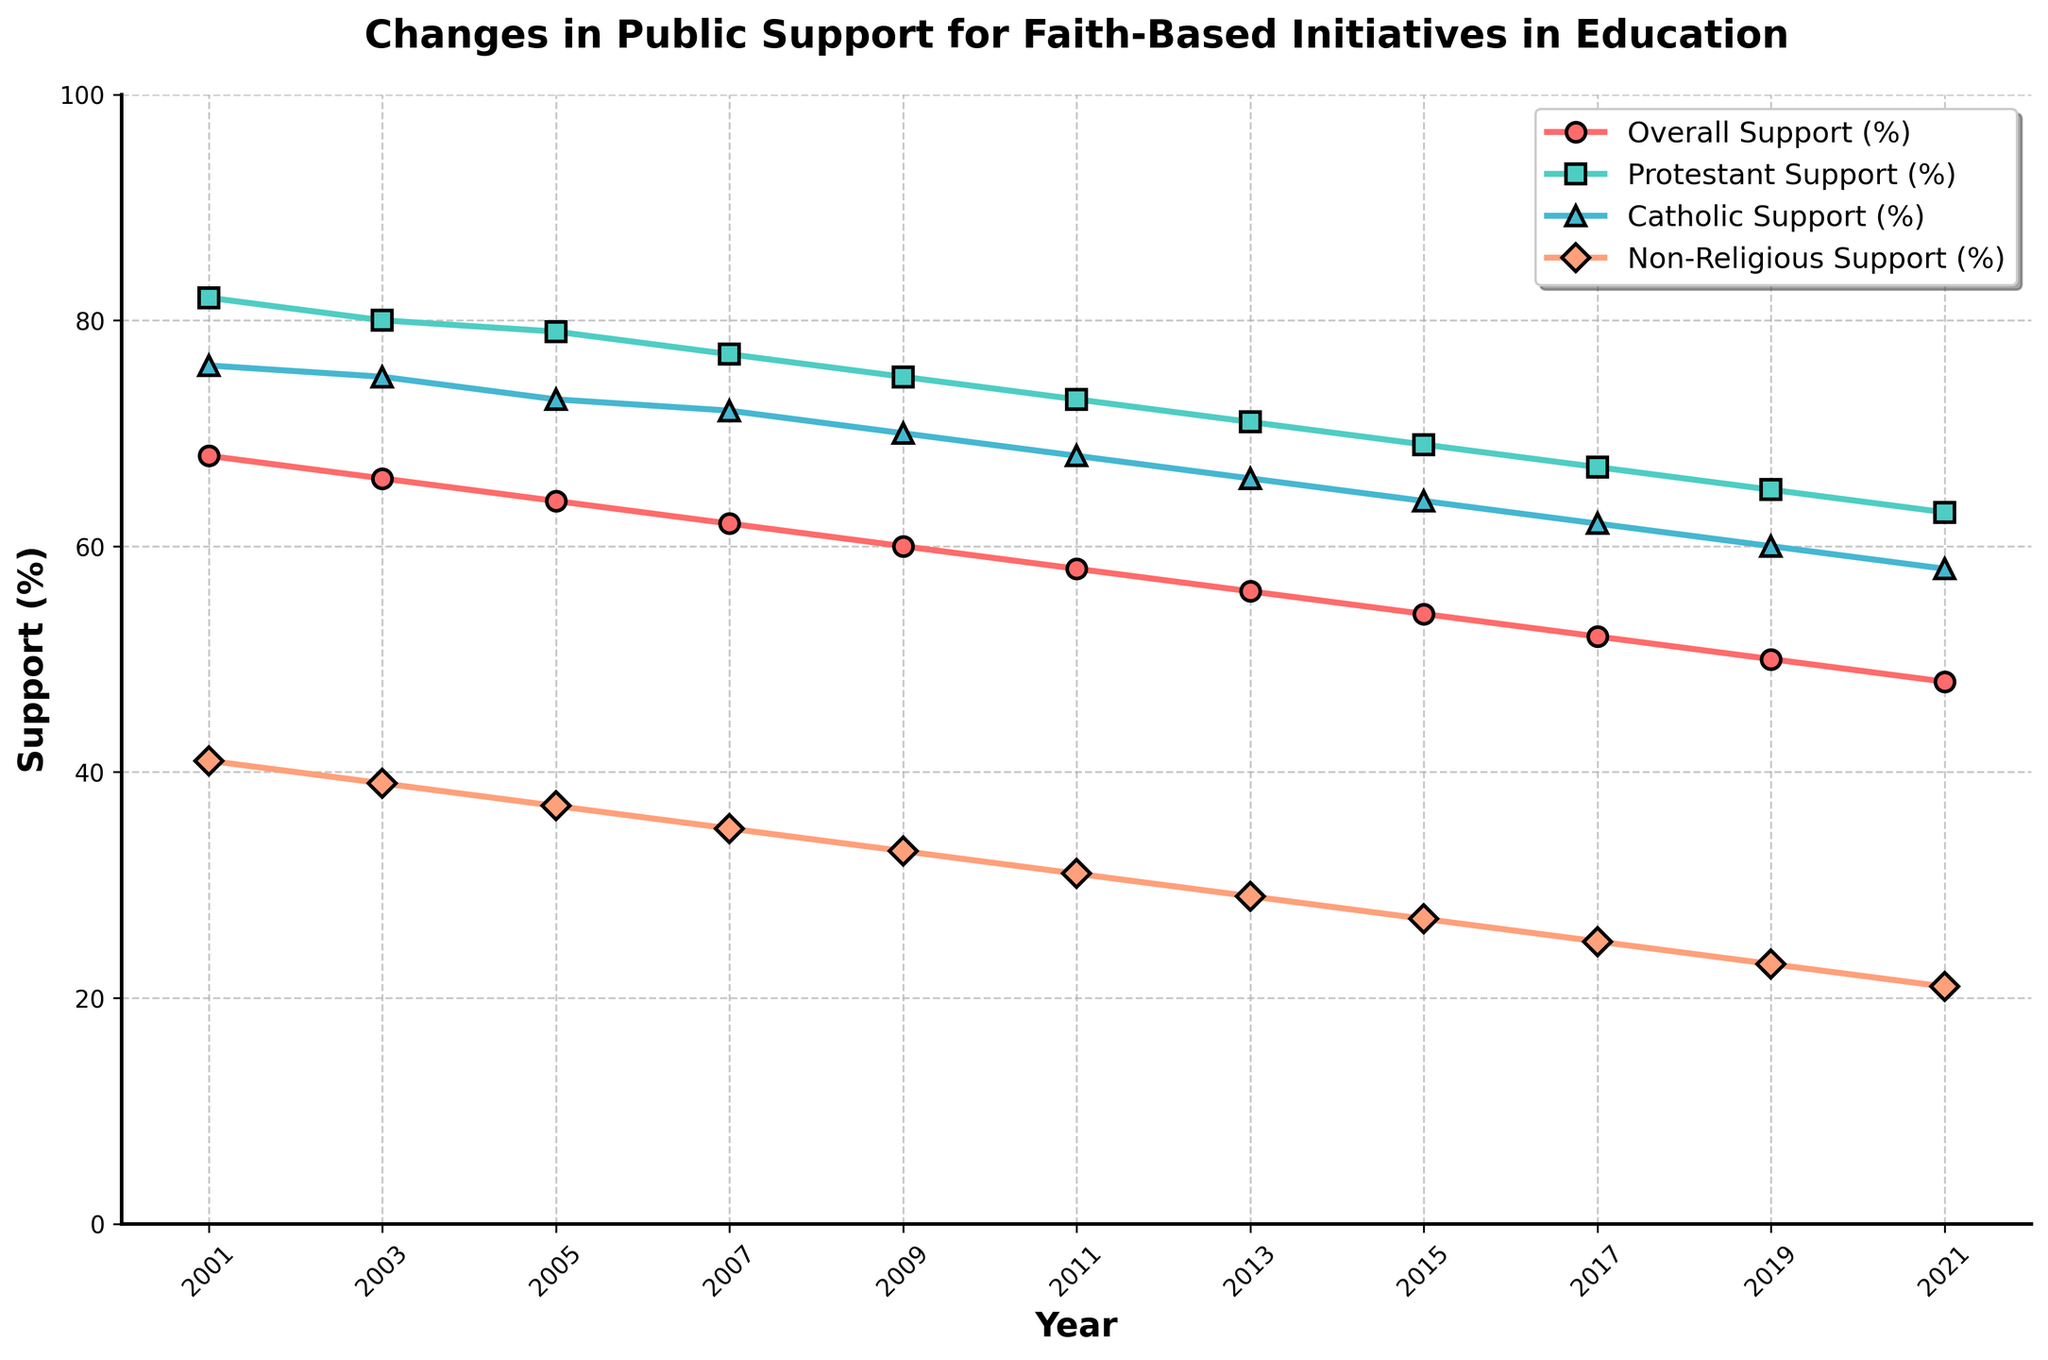What is the overall trend in public support for faith-based initiatives in education from 2001 to 2021? The overall trend is a consistent decline. From 2001 to 2021, overall support decreased from 68% to 48%.
Answer: Decline Which group had the highest level of support for faith-based initiatives in 2001? By examining the 2001 data points, the Protestant Support was the highest at 82%.
Answer: Protestant Support Between which two consecutive years was the largest decrease in Catholic Support (%) observed? To find this, calculate the difference between consecutive years for Catholic Support and find the maximum change. The biggest drop is between 2001 (76%) and 2003 (75%) which is a 1% decrease, and similar analysis can be done for each subsequent period. The largest observed decrease is from 2003 to 2005, where the support decreased by 2%.
Answer: 2003 to 2005 Compare the support trend between Protestant and Non-Religious groups from 2001 to 2021. Which group shows a steeper decline? The Protestant Support started at 82% in 2001 and declined to 63% in 2021, a 19% drop. The Non-Religious Support started at 41% in 2001 and declined to 21% in 2021, a 20% drop. Thus, Non-Religious shows a steeper decline.
Answer: Non-Religious In what year did the overall support (%) fall below 60% for the first time? Checking the data, overall support dropped to 58% in 2011, which is the first time it fell below 60%.
Answer: 2011 What is the average support (%) for faith-based initiatives among Catholics over the measured period? Sum the Catholic Support percentages from each year and divide by the number of years. (76+75+73+72+70+68+66+64+62+60+58)/11 = 68%.
Answer: 68% By how many percentage points did the support among the Non-Religious group change from 2001 to 2021? The support among Non-Religious changed from 41% in 2001 to 21% in 2021. Calculate the difference: 41% - 21% = 20%.
Answer: 20% Which year showed the smallest inter-group difference in support between Protestants and Catholics? Calculate the difference in support for each year between Protestants and Catholics and find the smallest value. The smallest difference is in 2019 where it's 5% (65-60).
Answer: 2019 What was the Protestant Support (%) in 2015, and how does it compare to the same group's support in 2001? Protestant Support in 2015 was 69%, compared to 82% in 2001, showing a decrease of 13% over the period.
Answer: 69%, decrease of 13% Which group's support for faith-based initiatives in education consistently fell below the overall support from 2001 to 2021? By comparing support percentages of each group with the overall support, it is clear that Non-Religious Support consistently fell below the overall support in all years from 2001 to 2021.
Answer: Non-Religious 